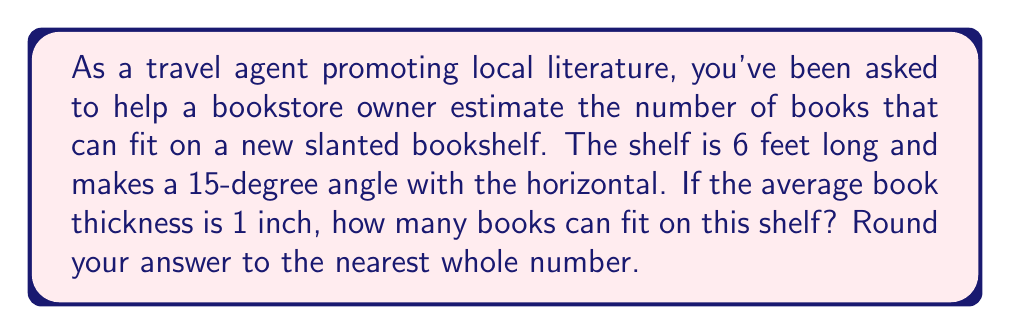Solve this math problem. To solve this problem, we'll use trigonometry to find the vertical height of the shelf, which will determine how many books can stand upright on it. Here's the step-by-step solution:

1. Visualize the shelf as the hypotenuse of a right triangle, where:
   - The angle between the shelf and the horizontal is 15°
   - The length of the shelf (hypotenuse) is 6 feet

2. We need to find the opposite side of this triangle, which represents the vertical height.

3. We can use the sine function to relate the angle to the opposite side and hypotenuse:

   $$\sin(\theta) = \frac{\text{opposite}}{\text{hypotenuse}}$$

4. Plugging in our known values:

   $$\sin(15°) = \frac{\text{height}}{6\text{ feet}}$$

5. Solve for height:

   $$\text{height} = 6 \text{ feet} \times \sin(15°)$$

6. Calculate:
   $$\text{height} = 6 \times 0.2588 = 1.5528 \text{ feet}$$

7. Convert feet to inches:
   $$1.5528 \text{ feet} \times 12 \text{ inches/foot} = 18.6336 \text{ inches}$$

8. To find the number of books, divide the height in inches by the thickness of one book:

   $$\text{Number of books} = \frac{18.6336 \text{ inches}}{1 \text{ inch/book}} = 18.6336$$

9. Round to the nearest whole number: 19 books
Answer: 19 books 